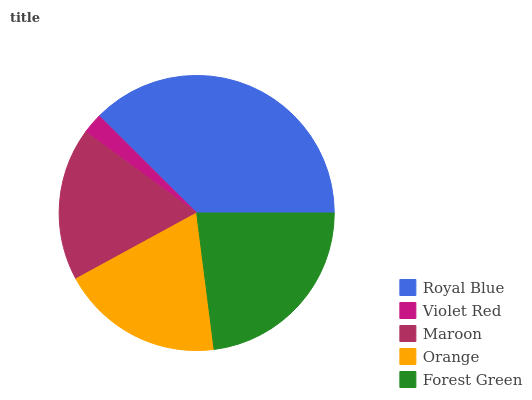Is Violet Red the minimum?
Answer yes or no. Yes. Is Royal Blue the maximum?
Answer yes or no. Yes. Is Maroon the minimum?
Answer yes or no. No. Is Maroon the maximum?
Answer yes or no. No. Is Maroon greater than Violet Red?
Answer yes or no. Yes. Is Violet Red less than Maroon?
Answer yes or no. Yes. Is Violet Red greater than Maroon?
Answer yes or no. No. Is Maroon less than Violet Red?
Answer yes or no. No. Is Orange the high median?
Answer yes or no. Yes. Is Orange the low median?
Answer yes or no. Yes. Is Forest Green the high median?
Answer yes or no. No. Is Forest Green the low median?
Answer yes or no. No. 